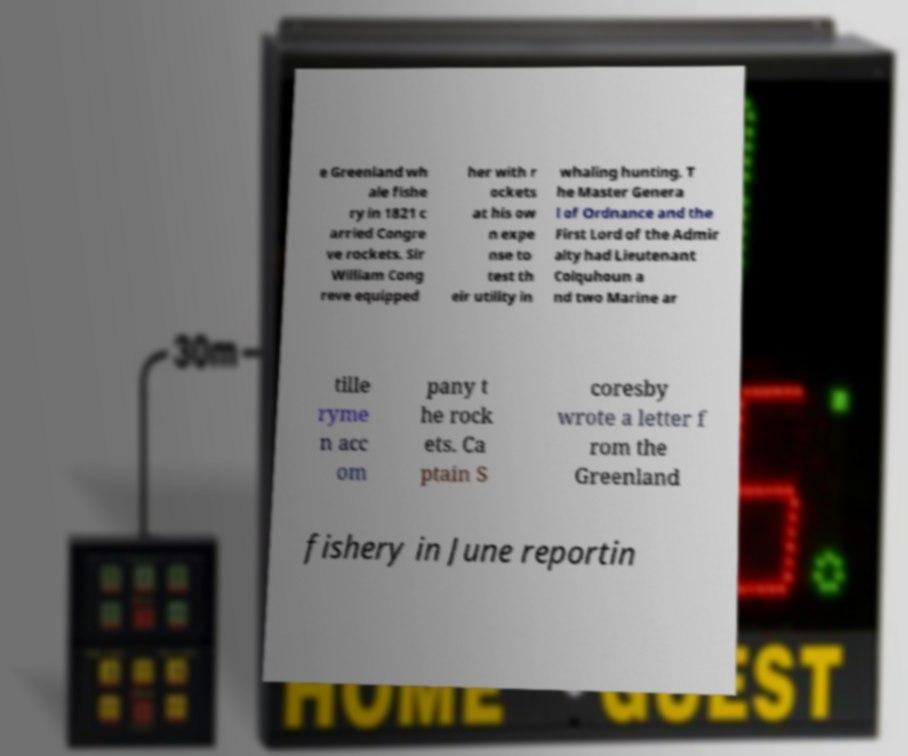Can you accurately transcribe the text from the provided image for me? e Greenland wh ale fishe ry in 1821 c arried Congre ve rockets. Sir William Cong reve equipped her with r ockets at his ow n expe nse to test th eir utility in whaling hunting. T he Master Genera l of Ordnance and the First Lord of the Admir alty had Lieutenant Colquhoun a nd two Marine ar tille ryme n acc om pany t he rock ets. Ca ptain S coresby wrote a letter f rom the Greenland fishery in June reportin 